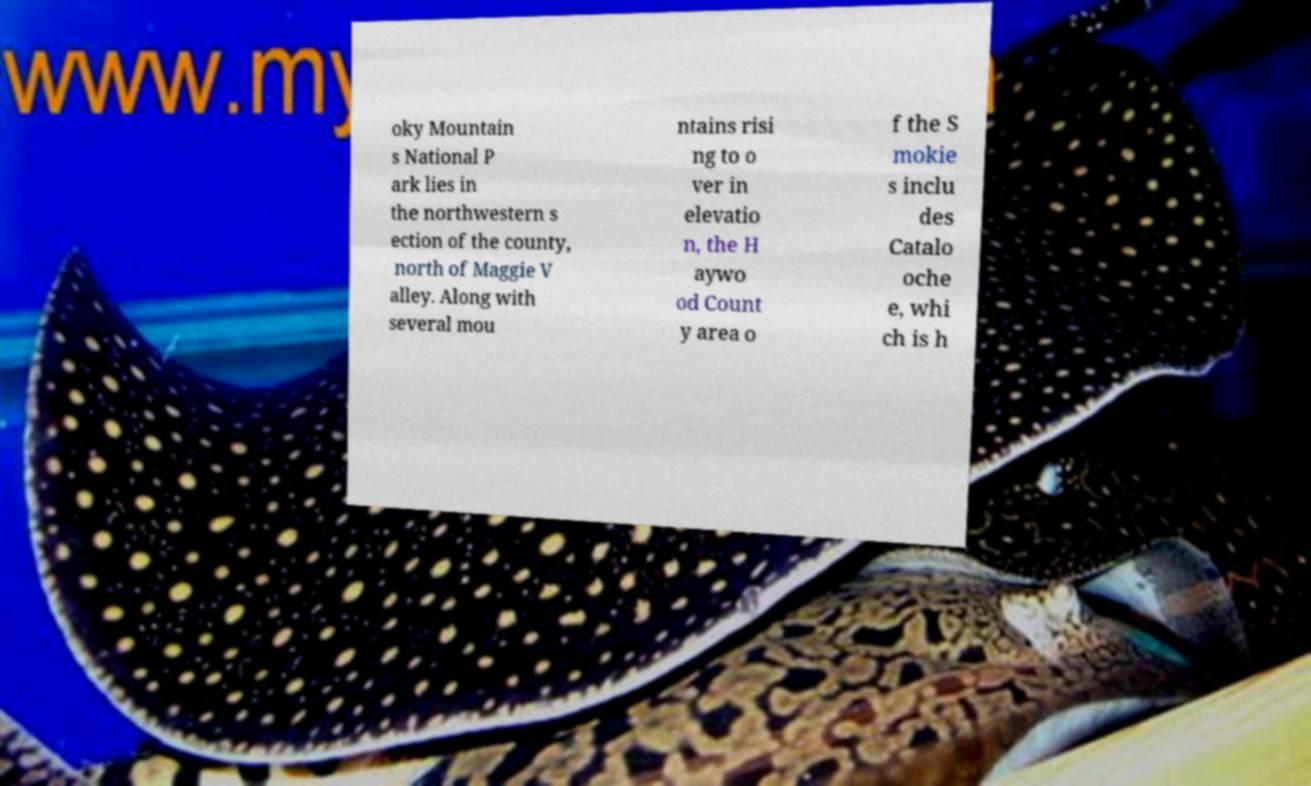Please read and relay the text visible in this image. What does it say? oky Mountain s National P ark lies in the northwestern s ection of the county, north of Maggie V alley. Along with several mou ntains risi ng to o ver in elevatio n, the H aywo od Count y area o f the S mokie s inclu des Catalo oche e, whi ch is h 